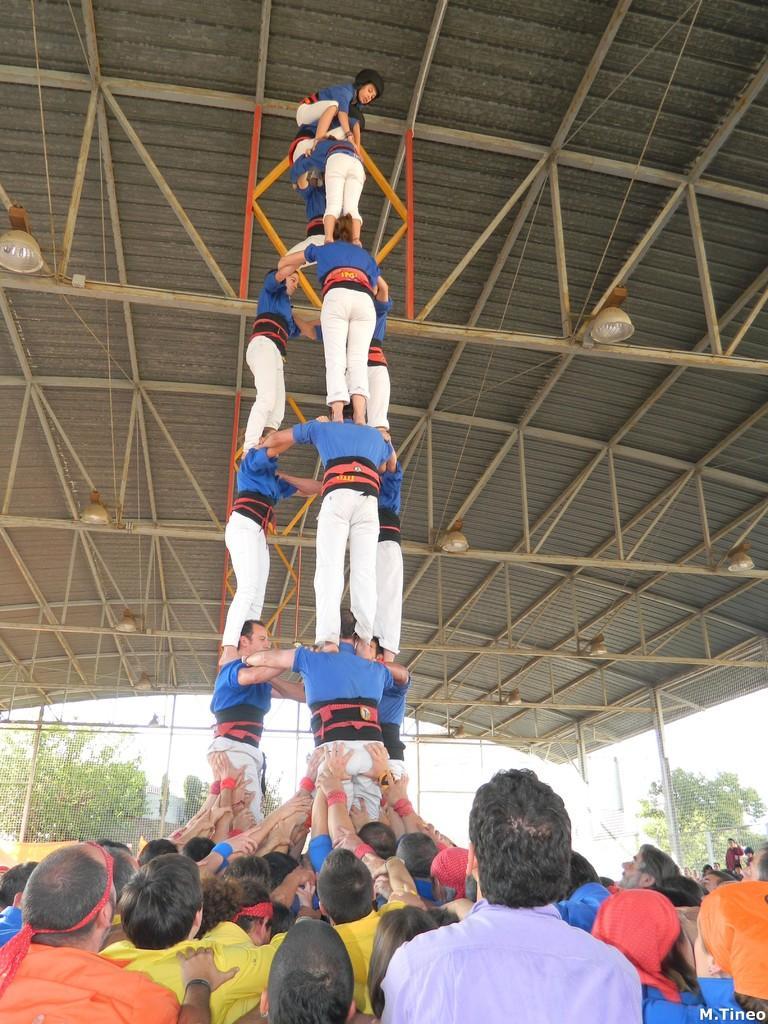Could you give a brief overview of what you see in this image? In this picture there are group of people performing acrobatics. At the bottom there are group of people standing. At the back there is a fence and there are trees. At the top there is sky and there is a roof and there are lights. At the bottom right there is text. 